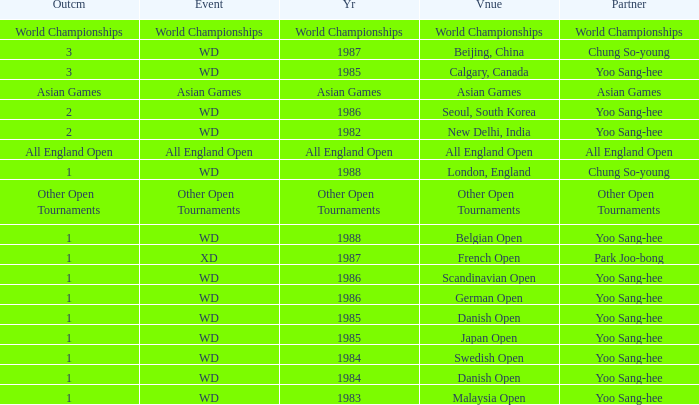What is the Outcome in the Malaysia Open with Partner Yoo Sang-Hee? 1.0. 